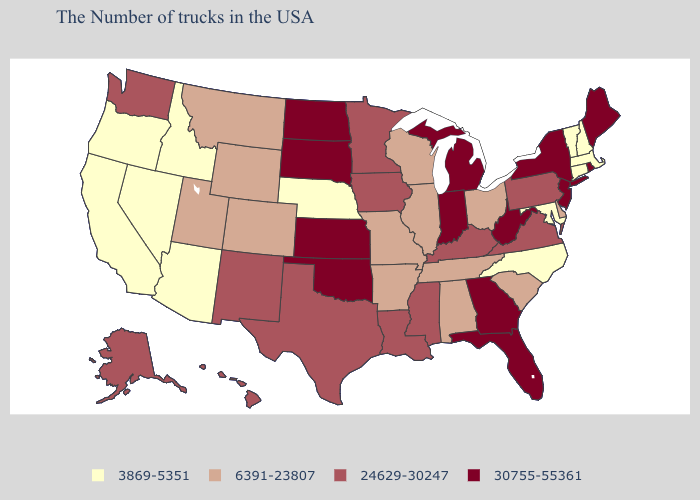Among the states that border New Mexico , does Arizona have the lowest value?
Write a very short answer. Yes. Does Colorado have the same value as New York?
Give a very brief answer. No. Name the states that have a value in the range 30755-55361?
Write a very short answer. Maine, Rhode Island, New York, New Jersey, West Virginia, Florida, Georgia, Michigan, Indiana, Kansas, Oklahoma, South Dakota, North Dakota. Name the states that have a value in the range 30755-55361?
Quick response, please. Maine, Rhode Island, New York, New Jersey, West Virginia, Florida, Georgia, Michigan, Indiana, Kansas, Oklahoma, South Dakota, North Dakota. Is the legend a continuous bar?
Quick response, please. No. Among the states that border Illinois , which have the lowest value?
Concise answer only. Wisconsin, Missouri. Name the states that have a value in the range 3869-5351?
Short answer required. Massachusetts, New Hampshire, Vermont, Connecticut, Maryland, North Carolina, Nebraska, Arizona, Idaho, Nevada, California, Oregon. Does Louisiana have a lower value than Rhode Island?
Answer briefly. Yes. What is the value of Minnesota?
Answer briefly. 24629-30247. Is the legend a continuous bar?
Short answer required. No. What is the value of West Virginia?
Give a very brief answer. 30755-55361. What is the lowest value in the South?
Give a very brief answer. 3869-5351. What is the lowest value in the West?
Be succinct. 3869-5351. What is the value of Tennessee?
Give a very brief answer. 6391-23807. What is the value of Kentucky?
Write a very short answer. 24629-30247. 